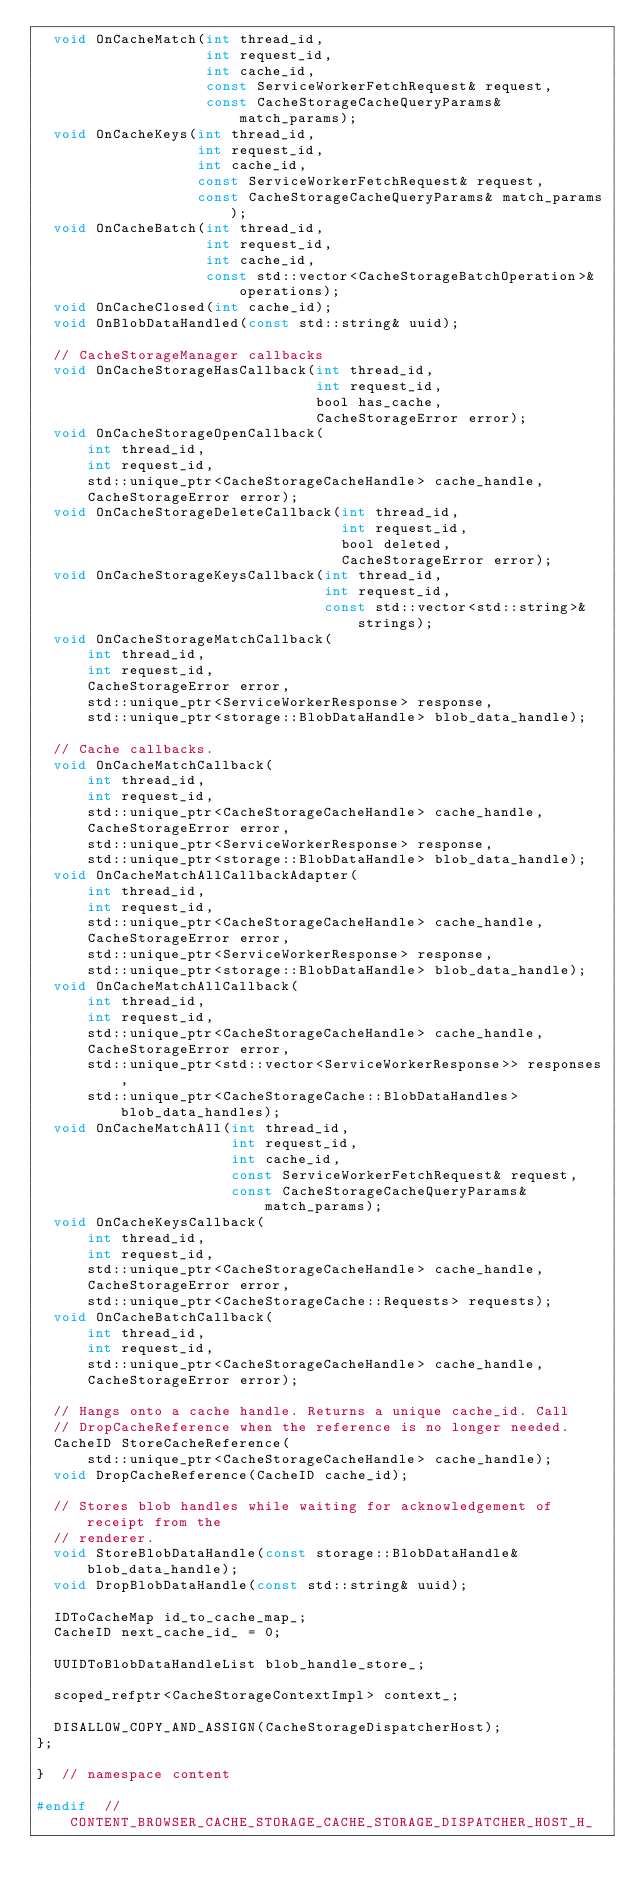<code> <loc_0><loc_0><loc_500><loc_500><_C_>  void OnCacheMatch(int thread_id,
                    int request_id,
                    int cache_id,
                    const ServiceWorkerFetchRequest& request,
                    const CacheStorageCacheQueryParams& match_params);
  void OnCacheKeys(int thread_id,
                   int request_id,
                   int cache_id,
                   const ServiceWorkerFetchRequest& request,
                   const CacheStorageCacheQueryParams& match_params);
  void OnCacheBatch(int thread_id,
                    int request_id,
                    int cache_id,
                    const std::vector<CacheStorageBatchOperation>& operations);
  void OnCacheClosed(int cache_id);
  void OnBlobDataHandled(const std::string& uuid);

  // CacheStorageManager callbacks
  void OnCacheStorageHasCallback(int thread_id,
                                 int request_id,
                                 bool has_cache,
                                 CacheStorageError error);
  void OnCacheStorageOpenCallback(
      int thread_id,
      int request_id,
      std::unique_ptr<CacheStorageCacheHandle> cache_handle,
      CacheStorageError error);
  void OnCacheStorageDeleteCallback(int thread_id,
                                    int request_id,
                                    bool deleted,
                                    CacheStorageError error);
  void OnCacheStorageKeysCallback(int thread_id,
                                  int request_id,
                                  const std::vector<std::string>& strings);
  void OnCacheStorageMatchCallback(
      int thread_id,
      int request_id,
      CacheStorageError error,
      std::unique_ptr<ServiceWorkerResponse> response,
      std::unique_ptr<storage::BlobDataHandle> blob_data_handle);

  // Cache callbacks.
  void OnCacheMatchCallback(
      int thread_id,
      int request_id,
      std::unique_ptr<CacheStorageCacheHandle> cache_handle,
      CacheStorageError error,
      std::unique_ptr<ServiceWorkerResponse> response,
      std::unique_ptr<storage::BlobDataHandle> blob_data_handle);
  void OnCacheMatchAllCallbackAdapter(
      int thread_id,
      int request_id,
      std::unique_ptr<CacheStorageCacheHandle> cache_handle,
      CacheStorageError error,
      std::unique_ptr<ServiceWorkerResponse> response,
      std::unique_ptr<storage::BlobDataHandle> blob_data_handle);
  void OnCacheMatchAllCallback(
      int thread_id,
      int request_id,
      std::unique_ptr<CacheStorageCacheHandle> cache_handle,
      CacheStorageError error,
      std::unique_ptr<std::vector<ServiceWorkerResponse>> responses,
      std::unique_ptr<CacheStorageCache::BlobDataHandles> blob_data_handles);
  void OnCacheMatchAll(int thread_id,
                       int request_id,
                       int cache_id,
                       const ServiceWorkerFetchRequest& request,
                       const CacheStorageCacheQueryParams& match_params);
  void OnCacheKeysCallback(
      int thread_id,
      int request_id,
      std::unique_ptr<CacheStorageCacheHandle> cache_handle,
      CacheStorageError error,
      std::unique_ptr<CacheStorageCache::Requests> requests);
  void OnCacheBatchCallback(
      int thread_id,
      int request_id,
      std::unique_ptr<CacheStorageCacheHandle> cache_handle,
      CacheStorageError error);

  // Hangs onto a cache handle. Returns a unique cache_id. Call
  // DropCacheReference when the reference is no longer needed.
  CacheID StoreCacheReference(
      std::unique_ptr<CacheStorageCacheHandle> cache_handle);
  void DropCacheReference(CacheID cache_id);

  // Stores blob handles while waiting for acknowledgement of receipt from the
  // renderer.
  void StoreBlobDataHandle(const storage::BlobDataHandle& blob_data_handle);
  void DropBlobDataHandle(const std::string& uuid);

  IDToCacheMap id_to_cache_map_;
  CacheID next_cache_id_ = 0;

  UUIDToBlobDataHandleList blob_handle_store_;

  scoped_refptr<CacheStorageContextImpl> context_;

  DISALLOW_COPY_AND_ASSIGN(CacheStorageDispatcherHost);
};

}  // namespace content

#endif  // CONTENT_BROWSER_CACHE_STORAGE_CACHE_STORAGE_DISPATCHER_HOST_H_
</code> 